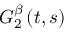<formula> <loc_0><loc_0><loc_500><loc_500>G _ { 2 } ^ { \beta } \left ( t , s \right )</formula> 